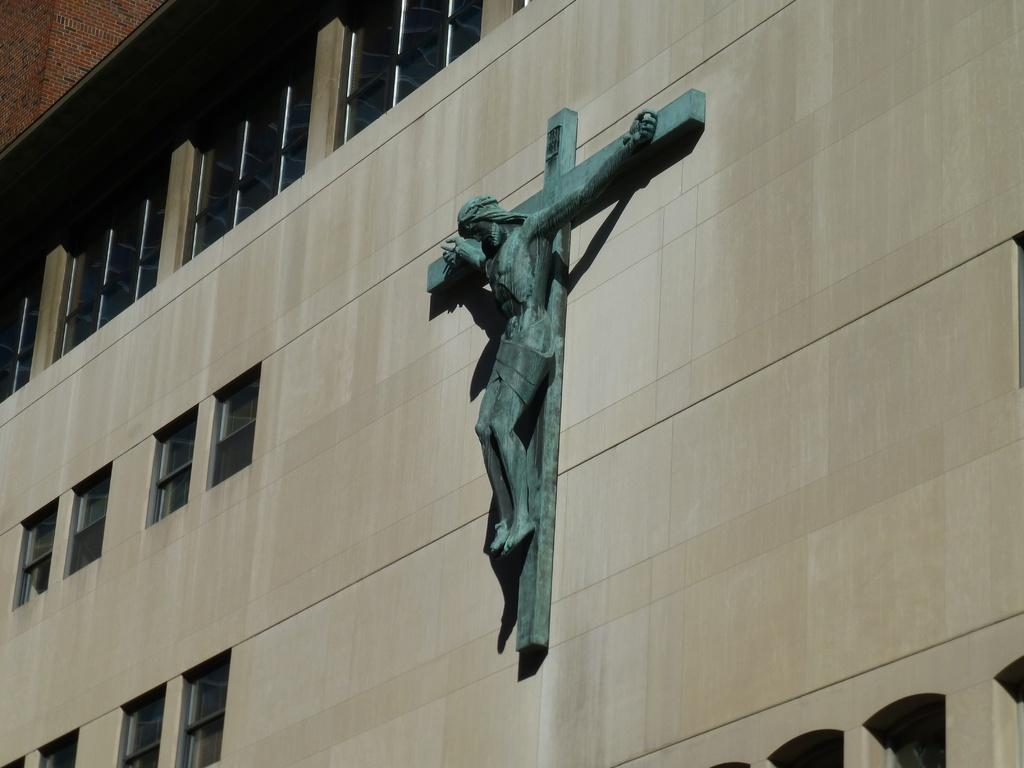What can be seen on the wall in the image? There is a startup logo on the wall in the image. What architectural feature is present on the left side of the image? There are multiple windows on the left side of the image. What type of jam is being served on the ship in the image? There is no ship or jam present in the image; it only features a startup logo on the wall and multiple windows on the left side. 